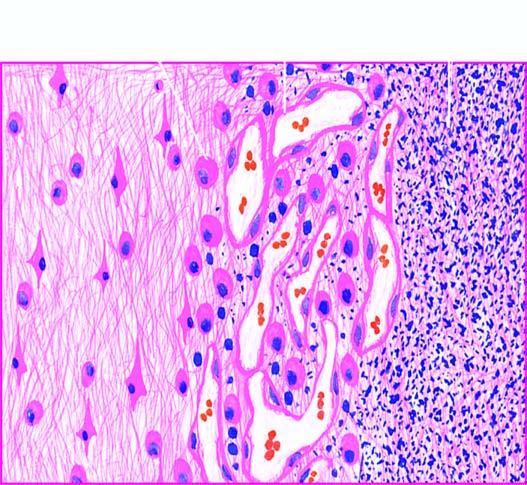does the cytoplasm show granulation tissue and gliosis?
Answer the question using a single word or phrase. No 